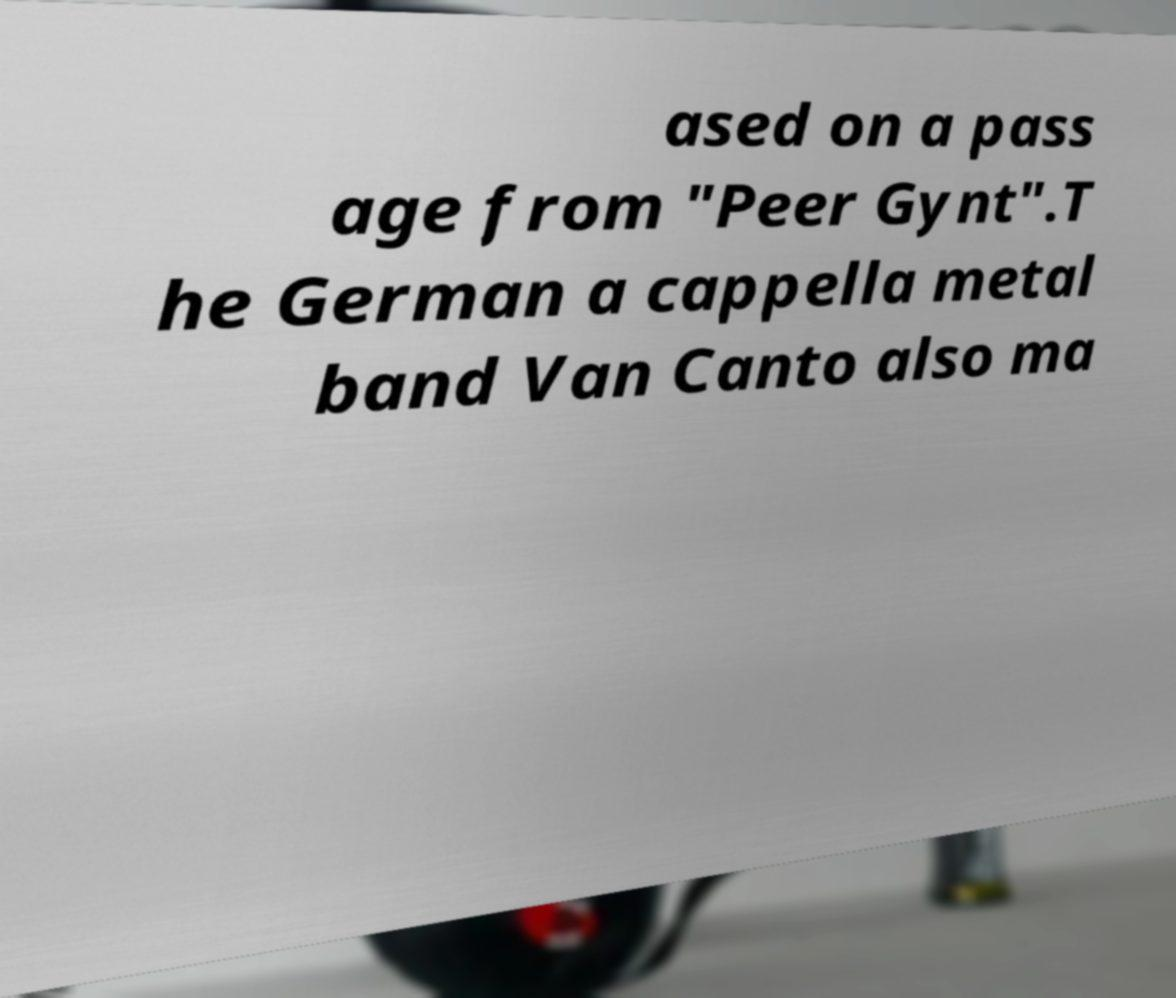Can you accurately transcribe the text from the provided image for me? ased on a pass age from "Peer Gynt".T he German a cappella metal band Van Canto also ma 